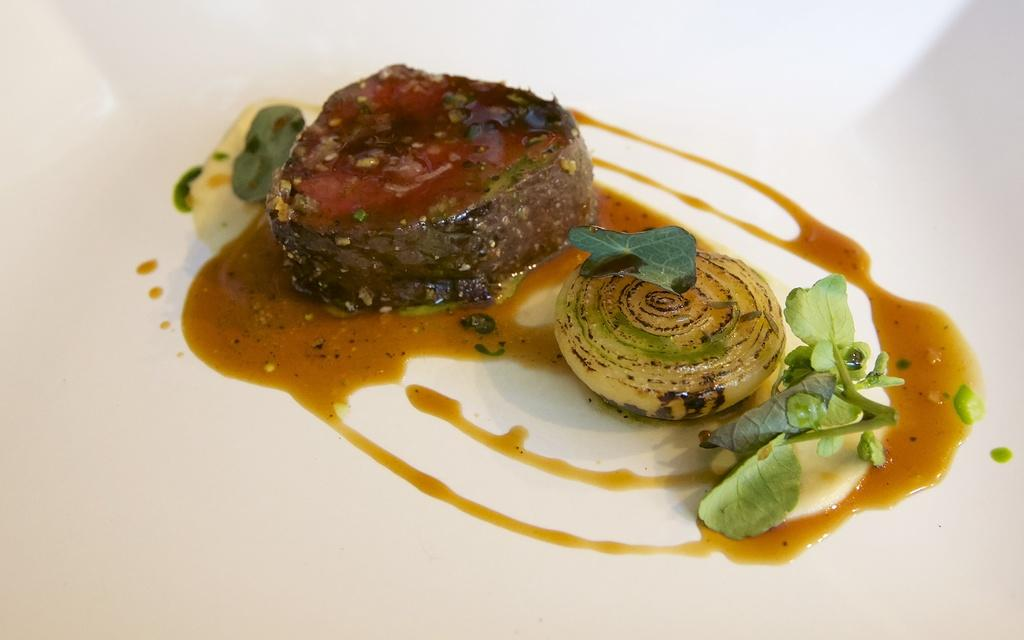What is the main subject of the image? The main subject of the image is food. Can you describe the surface on which the food is placed? The food is on a white surface. How does the grandmother push the sun in the image? There is no grandmother or sun present in the image. 